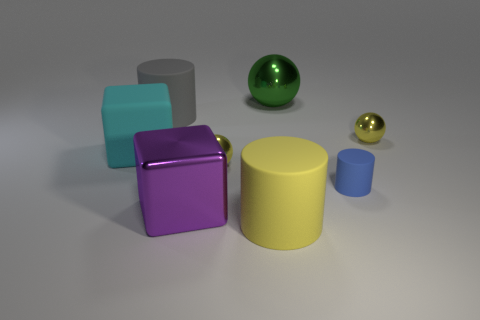Add 1 big purple cubes. How many objects exist? 9 Subtract all cubes. How many objects are left? 6 Add 7 blue rubber objects. How many blue rubber objects exist? 8 Subtract 0 cyan cylinders. How many objects are left? 8 Subtract all green objects. Subtract all spheres. How many objects are left? 4 Add 4 blue matte things. How many blue matte things are left? 5 